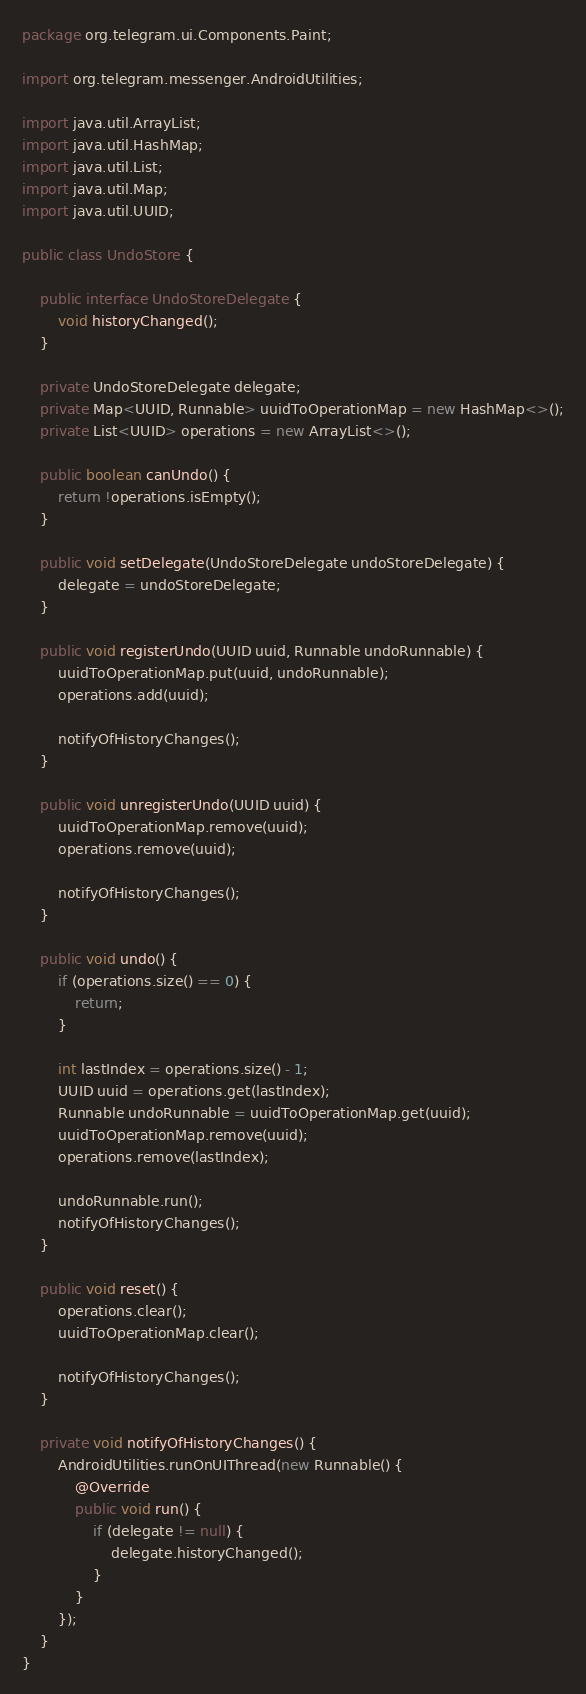<code> <loc_0><loc_0><loc_500><loc_500><_Java_>package org.telegram.ui.Components.Paint;

import org.telegram.messenger.AndroidUtilities;

import java.util.ArrayList;
import java.util.HashMap;
import java.util.List;
import java.util.Map;
import java.util.UUID;

public class UndoStore {

    public interface UndoStoreDelegate {
        void historyChanged();
    }

    private UndoStoreDelegate delegate;
    private Map<UUID, Runnable> uuidToOperationMap = new HashMap<>();
    private List<UUID> operations = new ArrayList<>();

    public boolean canUndo() {
        return !operations.isEmpty();
    }

    public void setDelegate(UndoStoreDelegate undoStoreDelegate) {
        delegate = undoStoreDelegate;
    }

    public void registerUndo(UUID uuid, Runnable undoRunnable) {
        uuidToOperationMap.put(uuid, undoRunnable);
        operations.add(uuid);

        notifyOfHistoryChanges();
    }

    public void unregisterUndo(UUID uuid) {
        uuidToOperationMap.remove(uuid);
        operations.remove(uuid);

        notifyOfHistoryChanges();
    }

    public void undo() {
        if (operations.size() == 0) {
            return;
        }

        int lastIndex = operations.size() - 1;
        UUID uuid = operations.get(lastIndex);
        Runnable undoRunnable = uuidToOperationMap.get(uuid);
        uuidToOperationMap.remove(uuid);
        operations.remove(lastIndex);

        undoRunnable.run();
        notifyOfHistoryChanges();
    }

    public void reset() {
        operations.clear();
        uuidToOperationMap.clear();

        notifyOfHistoryChanges();
    }

    private void notifyOfHistoryChanges() {
        AndroidUtilities.runOnUIThread(new Runnable() {
            @Override
            public void run() {
                if (delegate != null) {
                    delegate.historyChanged();
                }
            }
        });
    }
}
</code> 